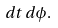Convert formula to latex. <formula><loc_0><loc_0><loc_500><loc_500>d t \, d \phi .</formula> 